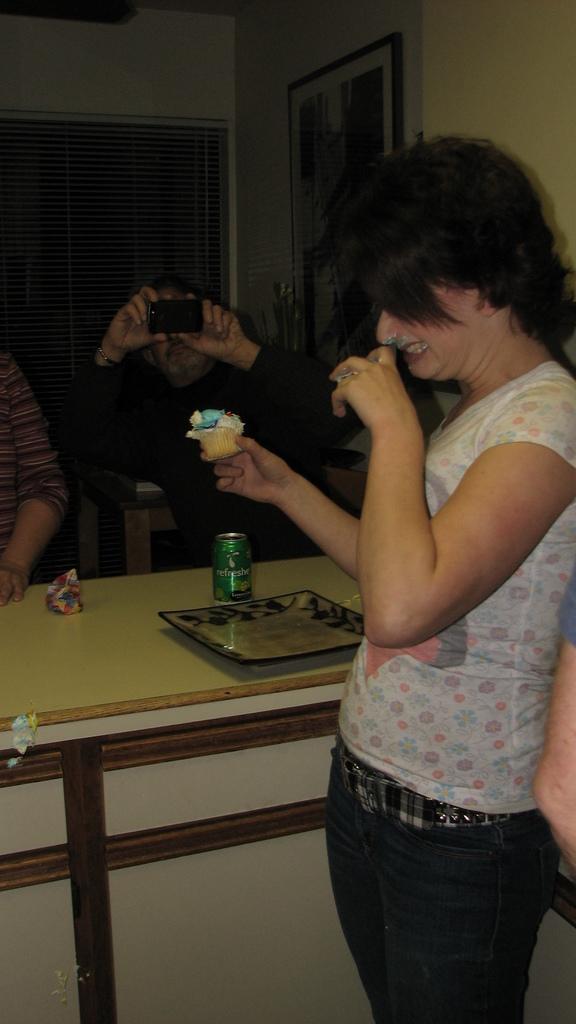Can you describe this image briefly? In this image I can see there are few persons visible in front of the table , on the table I can see cock tin and tray and a woman she is smiling and she holding a cake piece and a person wearing a black color t-shirt , holding a camera and I can see the wall and photo frame attached to the wall. 